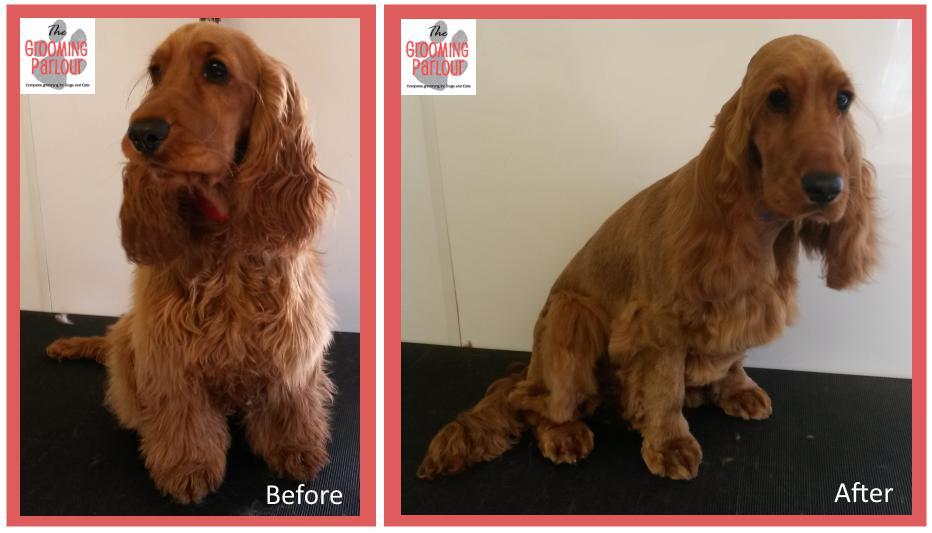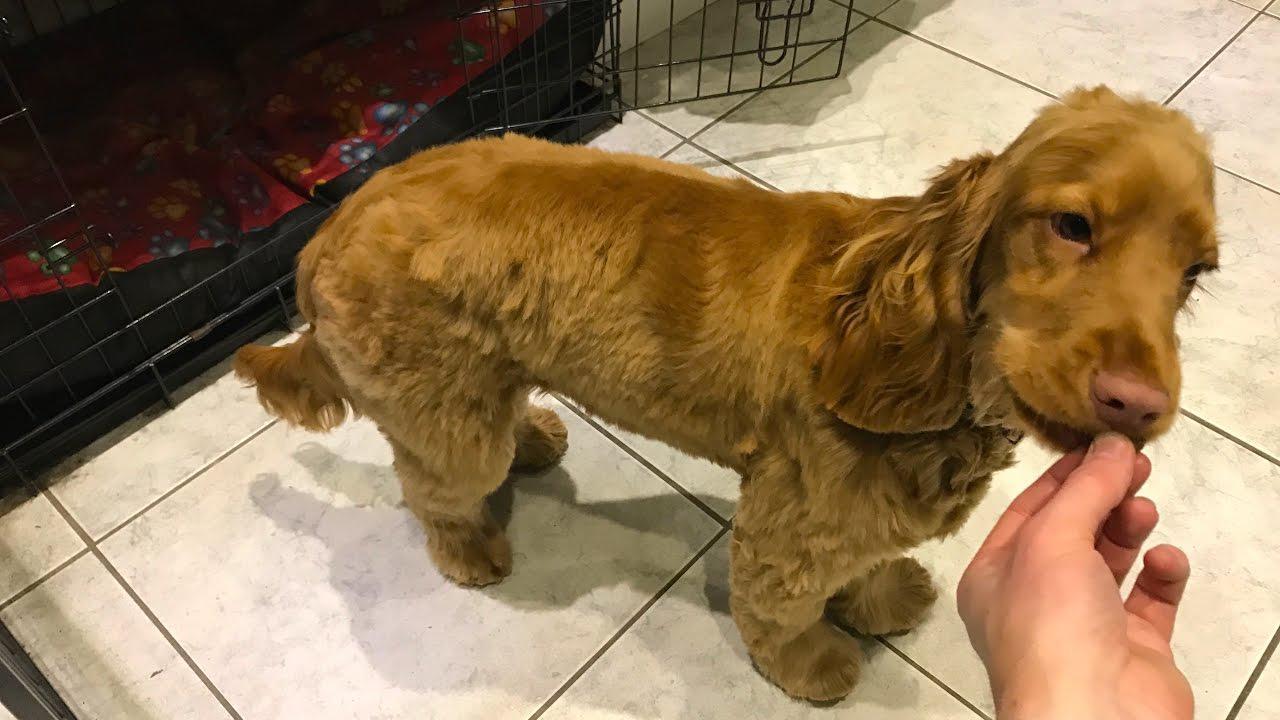The first image is the image on the left, the second image is the image on the right. Given the left and right images, does the statement "Each image contains a single spaniel dog, and the dogs in the left and right images have similar type body poses." hold true? Answer yes or no. No. The first image is the image on the left, the second image is the image on the right. Analyze the images presented: Is the assertion "There are at least three dogs in total." valid? Answer yes or no. Yes. 